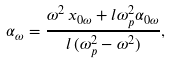<formula> <loc_0><loc_0><loc_500><loc_500>\alpha _ { \omega } = \frac { \omega ^ { 2 } \, x _ { 0 \omega } + l \omega _ { p } ^ { 2 } \alpha _ { 0 \omega } } { l \, ( \omega _ { p } ^ { 2 } - \omega ^ { 2 } ) } ,</formula> 